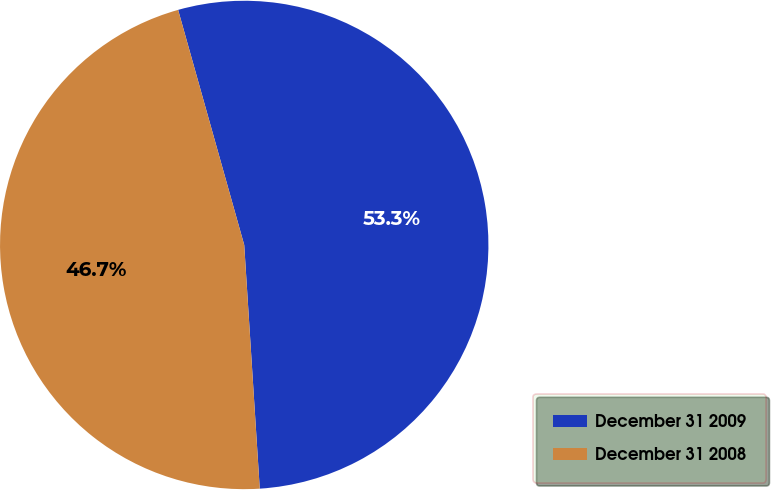<chart> <loc_0><loc_0><loc_500><loc_500><pie_chart><fcel>December 31 2009<fcel>December 31 2008<nl><fcel>53.35%<fcel>46.65%<nl></chart> 